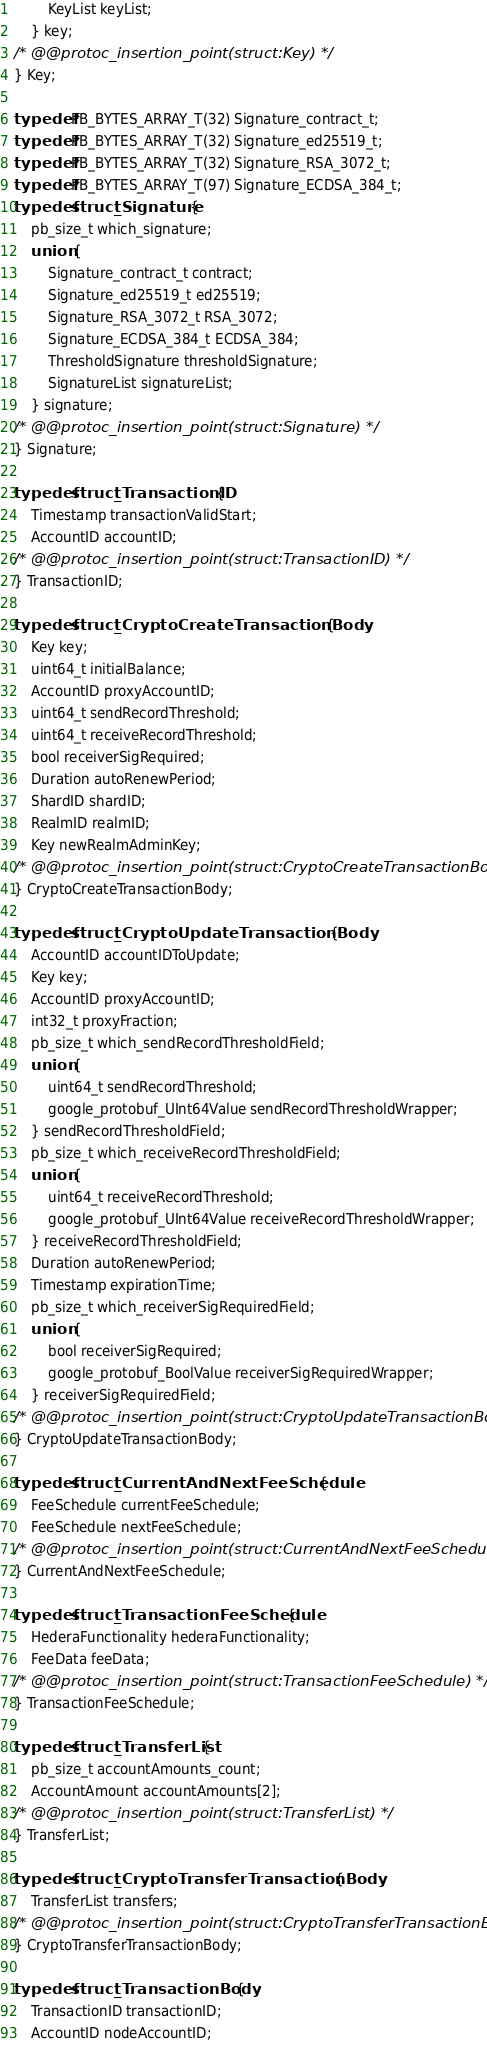<code> <loc_0><loc_0><loc_500><loc_500><_C_>        KeyList keyList;
    } key;
/* @@protoc_insertion_point(struct:Key) */
} Key;

typedef PB_BYTES_ARRAY_T(32) Signature_contract_t;
typedef PB_BYTES_ARRAY_T(32) Signature_ed25519_t;
typedef PB_BYTES_ARRAY_T(32) Signature_RSA_3072_t;
typedef PB_BYTES_ARRAY_T(97) Signature_ECDSA_384_t;
typedef struct _Signature {
    pb_size_t which_signature;
    union {
        Signature_contract_t contract;
        Signature_ed25519_t ed25519;
        Signature_RSA_3072_t RSA_3072;
        Signature_ECDSA_384_t ECDSA_384;
        ThresholdSignature thresholdSignature;
        SignatureList signatureList;
    } signature;
/* @@protoc_insertion_point(struct:Signature) */
} Signature;

typedef struct _TransactionID {
    Timestamp transactionValidStart;
    AccountID accountID;
/* @@protoc_insertion_point(struct:TransactionID) */
} TransactionID;

typedef struct _CryptoCreateTransactionBody {
    Key key;
    uint64_t initialBalance;
    AccountID proxyAccountID;
    uint64_t sendRecordThreshold;
    uint64_t receiveRecordThreshold;
    bool receiverSigRequired;
    Duration autoRenewPeriod;
    ShardID shardID;
    RealmID realmID;
    Key newRealmAdminKey;
/* @@protoc_insertion_point(struct:CryptoCreateTransactionBody) */
} CryptoCreateTransactionBody;

typedef struct _CryptoUpdateTransactionBody {
    AccountID accountIDToUpdate;
    Key key;
    AccountID proxyAccountID;
    int32_t proxyFraction;
    pb_size_t which_sendRecordThresholdField;
    union {
        uint64_t sendRecordThreshold;
        google_protobuf_UInt64Value sendRecordThresholdWrapper;
    } sendRecordThresholdField;
    pb_size_t which_receiveRecordThresholdField;
    union {
        uint64_t receiveRecordThreshold;
        google_protobuf_UInt64Value receiveRecordThresholdWrapper;
    } receiveRecordThresholdField;
    Duration autoRenewPeriod;
    Timestamp expirationTime;
    pb_size_t which_receiverSigRequiredField;
    union {
        bool receiverSigRequired;
        google_protobuf_BoolValue receiverSigRequiredWrapper;
    } receiverSigRequiredField;
/* @@protoc_insertion_point(struct:CryptoUpdateTransactionBody) */
} CryptoUpdateTransactionBody;

typedef struct _CurrentAndNextFeeSchedule {
    FeeSchedule currentFeeSchedule;
    FeeSchedule nextFeeSchedule;
/* @@protoc_insertion_point(struct:CurrentAndNextFeeSchedule) */
} CurrentAndNextFeeSchedule;

typedef struct _TransactionFeeSchedule {
    HederaFunctionality hederaFunctionality;
    FeeData feeData;
/* @@protoc_insertion_point(struct:TransactionFeeSchedule) */
} TransactionFeeSchedule;

typedef struct _TransferList {
    pb_size_t accountAmounts_count;
    AccountAmount accountAmounts[2];
/* @@protoc_insertion_point(struct:TransferList) */
} TransferList;

typedef struct _CryptoTransferTransactionBody {
    TransferList transfers;
/* @@protoc_insertion_point(struct:CryptoTransferTransactionBody) */
} CryptoTransferTransactionBody;

typedef struct _TransactionBody {
    TransactionID transactionID;
    AccountID nodeAccountID;</code> 